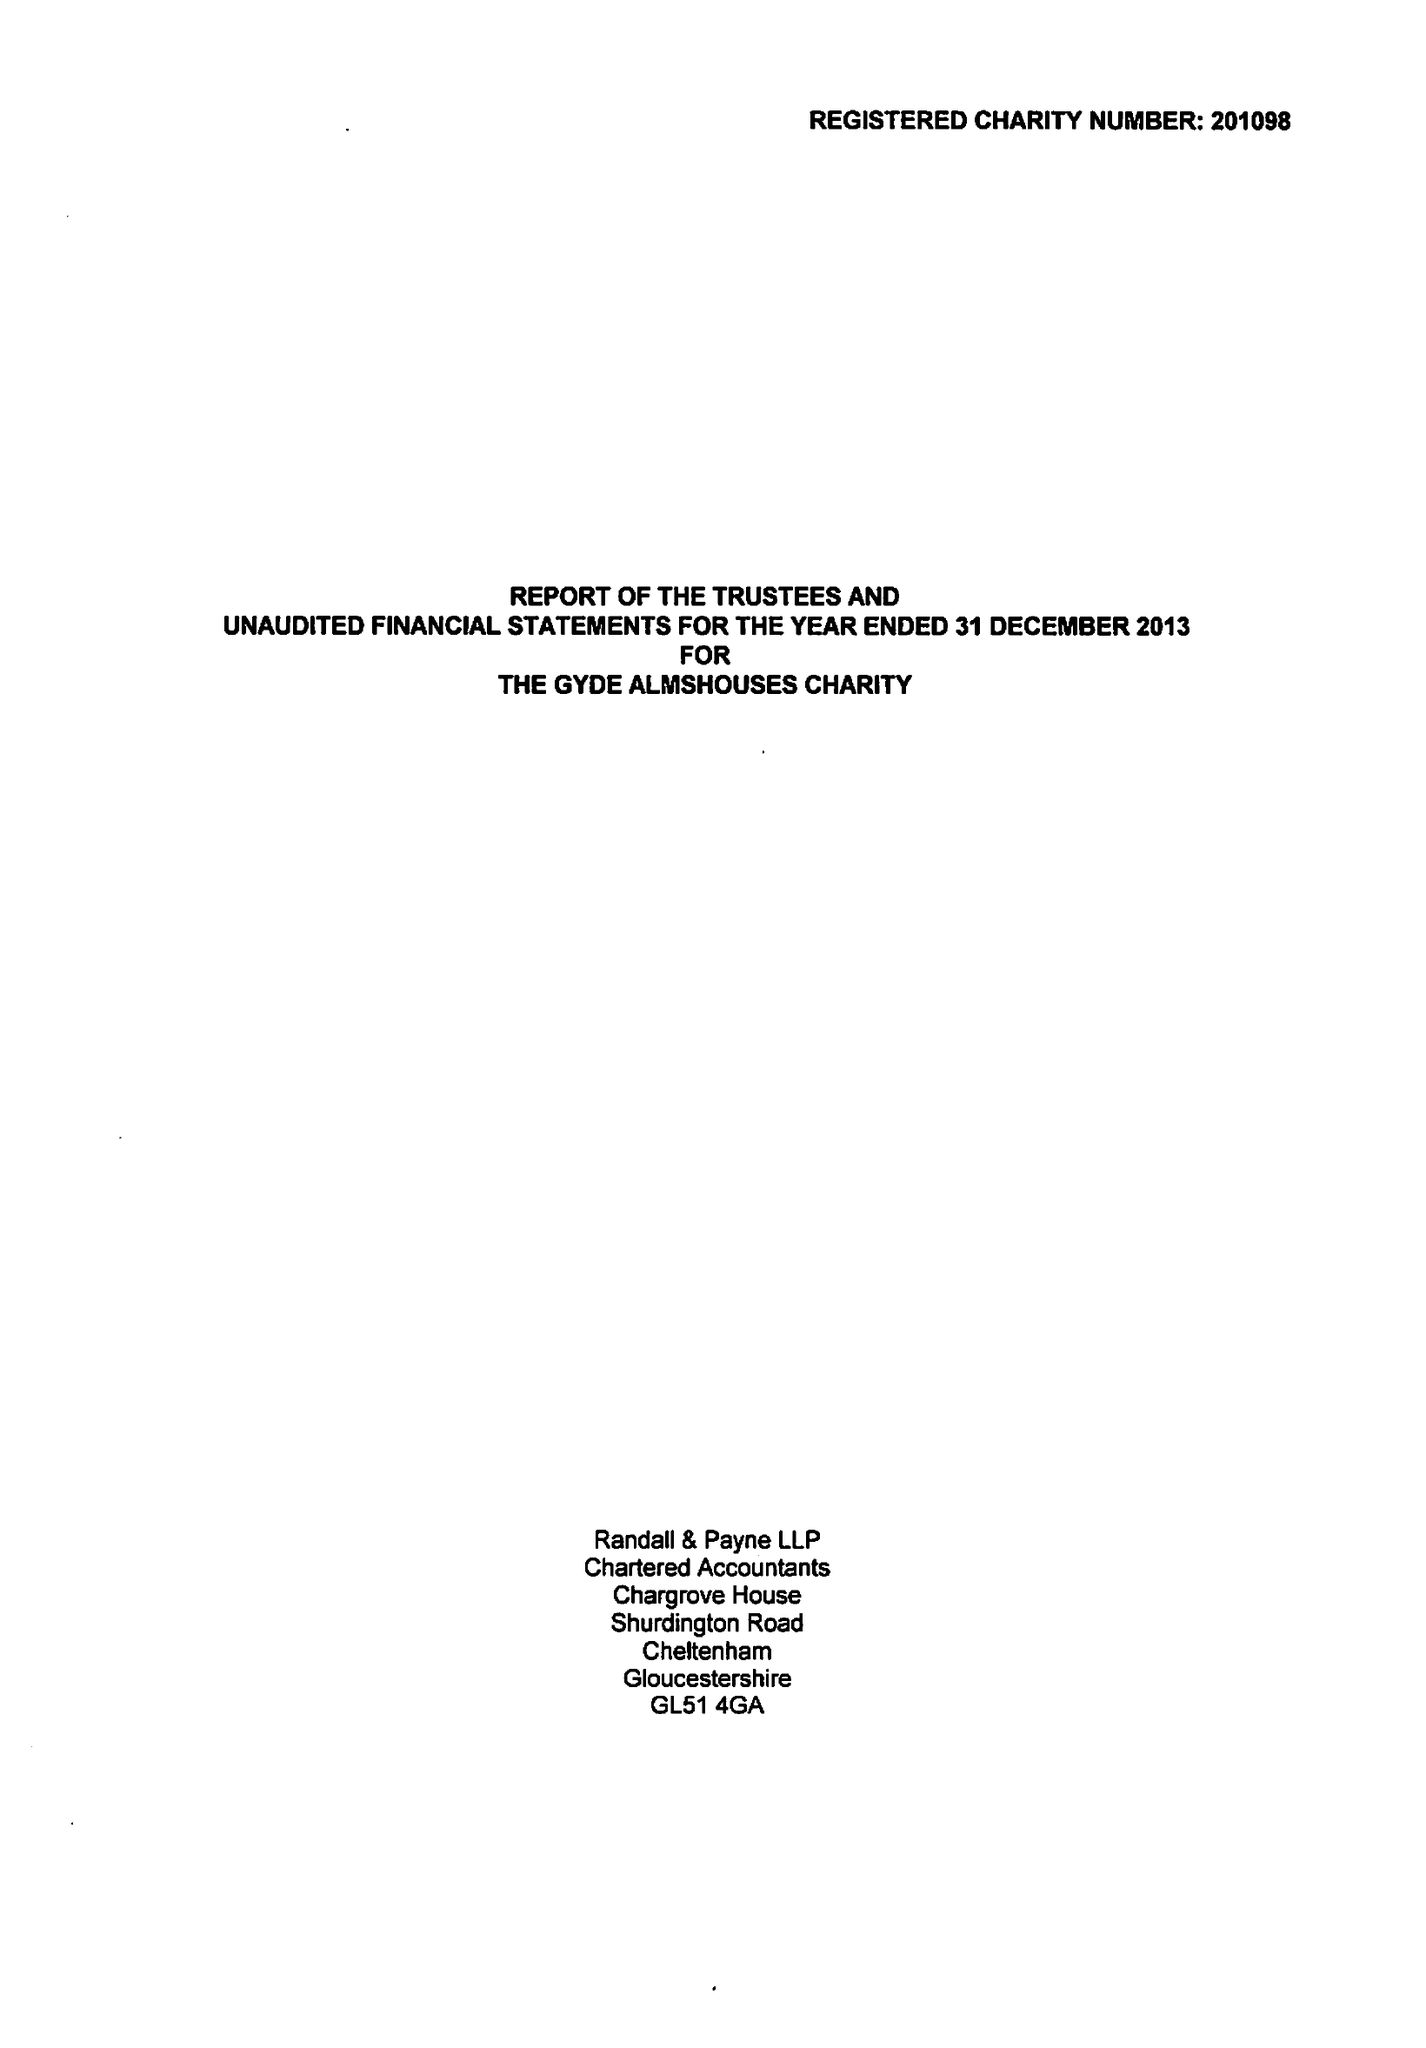What is the value for the spending_annually_in_british_pounds?
Answer the question using a single word or phrase. 21421.00 